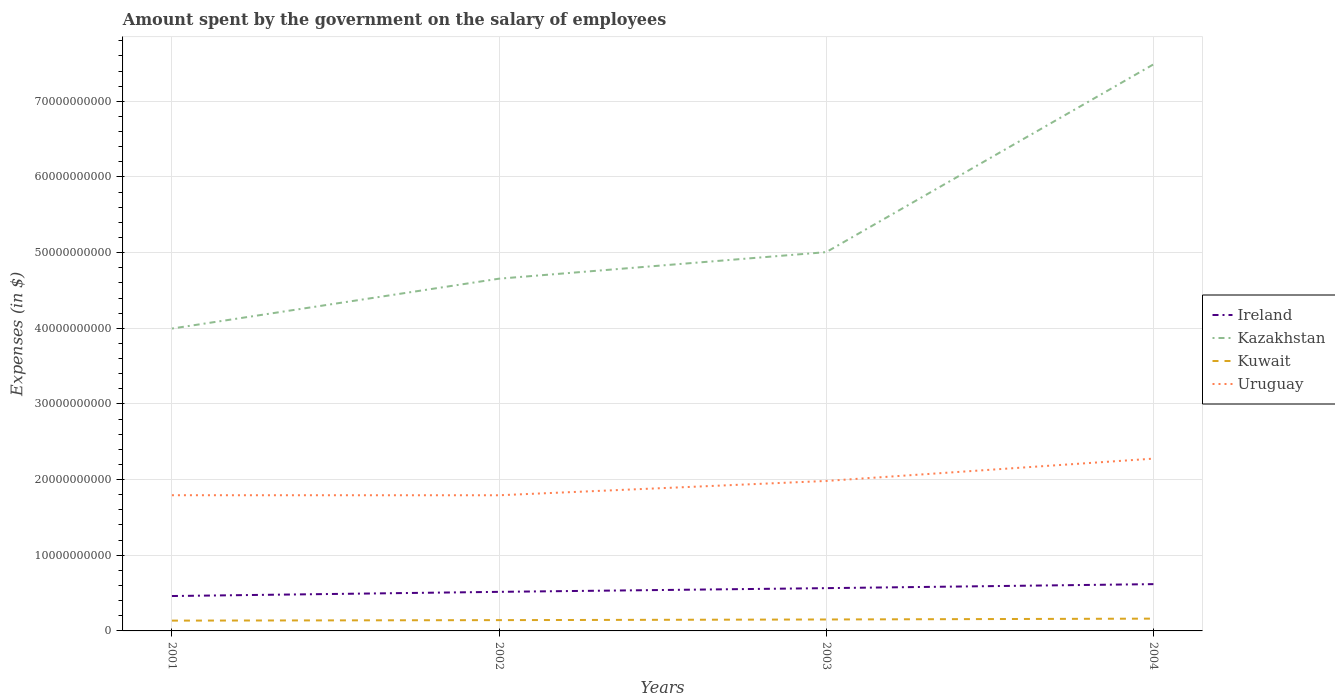How many different coloured lines are there?
Your answer should be compact. 4. Does the line corresponding to Kuwait intersect with the line corresponding to Ireland?
Ensure brevity in your answer.  No. Across all years, what is the maximum amount spent on the salary of employees by the government in Kazakhstan?
Provide a short and direct response. 4.00e+1. In which year was the amount spent on the salary of employees by the government in Kuwait maximum?
Ensure brevity in your answer.  2001. What is the total amount spent on the salary of employees by the government in Ireland in the graph?
Offer a terse response. -5.53e+08. What is the difference between the highest and the second highest amount spent on the salary of employees by the government in Kazakhstan?
Your answer should be compact. 3.49e+1. How many years are there in the graph?
Give a very brief answer. 4. Does the graph contain any zero values?
Your answer should be very brief. No. How many legend labels are there?
Your response must be concise. 4. What is the title of the graph?
Your response must be concise. Amount spent by the government on the salary of employees. What is the label or title of the Y-axis?
Ensure brevity in your answer.  Expenses (in $). What is the Expenses (in $) of Ireland in 2001?
Ensure brevity in your answer.  4.61e+09. What is the Expenses (in $) in Kazakhstan in 2001?
Your answer should be compact. 4.00e+1. What is the Expenses (in $) of Kuwait in 2001?
Keep it short and to the point. 1.36e+09. What is the Expenses (in $) in Uruguay in 2001?
Your answer should be very brief. 1.79e+1. What is the Expenses (in $) of Ireland in 2002?
Ensure brevity in your answer.  5.16e+09. What is the Expenses (in $) of Kazakhstan in 2002?
Keep it short and to the point. 4.66e+1. What is the Expenses (in $) in Kuwait in 2002?
Offer a very short reply. 1.43e+09. What is the Expenses (in $) of Uruguay in 2002?
Offer a very short reply. 1.79e+1. What is the Expenses (in $) of Ireland in 2003?
Provide a succinct answer. 5.65e+09. What is the Expenses (in $) in Kazakhstan in 2003?
Make the answer very short. 5.01e+1. What is the Expenses (in $) of Kuwait in 2003?
Offer a terse response. 1.51e+09. What is the Expenses (in $) in Uruguay in 2003?
Your response must be concise. 1.98e+1. What is the Expenses (in $) of Ireland in 2004?
Provide a short and direct response. 6.18e+09. What is the Expenses (in $) of Kazakhstan in 2004?
Keep it short and to the point. 7.49e+1. What is the Expenses (in $) in Kuwait in 2004?
Provide a succinct answer. 1.62e+09. What is the Expenses (in $) in Uruguay in 2004?
Your answer should be very brief. 2.28e+1. Across all years, what is the maximum Expenses (in $) of Ireland?
Your response must be concise. 6.18e+09. Across all years, what is the maximum Expenses (in $) of Kazakhstan?
Offer a very short reply. 7.49e+1. Across all years, what is the maximum Expenses (in $) in Kuwait?
Offer a very short reply. 1.62e+09. Across all years, what is the maximum Expenses (in $) of Uruguay?
Make the answer very short. 2.28e+1. Across all years, what is the minimum Expenses (in $) of Ireland?
Give a very brief answer. 4.61e+09. Across all years, what is the minimum Expenses (in $) in Kazakhstan?
Offer a terse response. 4.00e+1. Across all years, what is the minimum Expenses (in $) of Kuwait?
Keep it short and to the point. 1.36e+09. Across all years, what is the minimum Expenses (in $) of Uruguay?
Your answer should be very brief. 1.79e+1. What is the total Expenses (in $) in Ireland in the graph?
Make the answer very short. 2.16e+1. What is the total Expenses (in $) in Kazakhstan in the graph?
Your response must be concise. 2.11e+11. What is the total Expenses (in $) in Kuwait in the graph?
Ensure brevity in your answer.  5.93e+09. What is the total Expenses (in $) of Uruguay in the graph?
Your response must be concise. 7.85e+1. What is the difference between the Expenses (in $) in Ireland in 2001 and that in 2002?
Offer a very short reply. -5.53e+08. What is the difference between the Expenses (in $) in Kazakhstan in 2001 and that in 2002?
Your response must be concise. -6.59e+09. What is the difference between the Expenses (in $) in Kuwait in 2001 and that in 2002?
Provide a short and direct response. -6.50e+07. What is the difference between the Expenses (in $) in Uruguay in 2001 and that in 2002?
Your answer should be very brief. 5.24e+06. What is the difference between the Expenses (in $) of Ireland in 2001 and that in 2003?
Offer a terse response. -1.04e+09. What is the difference between the Expenses (in $) of Kazakhstan in 2001 and that in 2003?
Your answer should be very brief. -1.01e+1. What is the difference between the Expenses (in $) of Kuwait in 2001 and that in 2003?
Ensure brevity in your answer.  -1.50e+08. What is the difference between the Expenses (in $) in Uruguay in 2001 and that in 2003?
Keep it short and to the point. -1.89e+09. What is the difference between the Expenses (in $) in Ireland in 2001 and that in 2004?
Keep it short and to the point. -1.57e+09. What is the difference between the Expenses (in $) in Kazakhstan in 2001 and that in 2004?
Your response must be concise. -3.49e+1. What is the difference between the Expenses (in $) in Kuwait in 2001 and that in 2004?
Offer a very short reply. -2.63e+08. What is the difference between the Expenses (in $) in Uruguay in 2001 and that in 2004?
Your answer should be compact. -4.84e+09. What is the difference between the Expenses (in $) in Ireland in 2002 and that in 2003?
Give a very brief answer. -4.88e+08. What is the difference between the Expenses (in $) in Kazakhstan in 2002 and that in 2003?
Ensure brevity in your answer.  -3.51e+09. What is the difference between the Expenses (in $) of Kuwait in 2002 and that in 2003?
Provide a short and direct response. -8.50e+07. What is the difference between the Expenses (in $) of Uruguay in 2002 and that in 2003?
Make the answer very short. -1.89e+09. What is the difference between the Expenses (in $) of Ireland in 2002 and that in 2004?
Make the answer very short. -1.02e+09. What is the difference between the Expenses (in $) in Kazakhstan in 2002 and that in 2004?
Your answer should be very brief. -2.83e+1. What is the difference between the Expenses (in $) of Kuwait in 2002 and that in 2004?
Provide a succinct answer. -1.98e+08. What is the difference between the Expenses (in $) in Uruguay in 2002 and that in 2004?
Your answer should be compact. -4.84e+09. What is the difference between the Expenses (in $) of Ireland in 2003 and that in 2004?
Your response must be concise. -5.31e+08. What is the difference between the Expenses (in $) in Kazakhstan in 2003 and that in 2004?
Give a very brief answer. -2.48e+1. What is the difference between the Expenses (in $) of Kuwait in 2003 and that in 2004?
Your answer should be very brief. -1.13e+08. What is the difference between the Expenses (in $) in Uruguay in 2003 and that in 2004?
Ensure brevity in your answer.  -2.95e+09. What is the difference between the Expenses (in $) in Ireland in 2001 and the Expenses (in $) in Kazakhstan in 2002?
Give a very brief answer. -4.19e+1. What is the difference between the Expenses (in $) of Ireland in 2001 and the Expenses (in $) of Kuwait in 2002?
Offer a terse response. 3.18e+09. What is the difference between the Expenses (in $) of Ireland in 2001 and the Expenses (in $) of Uruguay in 2002?
Keep it short and to the point. -1.33e+1. What is the difference between the Expenses (in $) of Kazakhstan in 2001 and the Expenses (in $) of Kuwait in 2002?
Keep it short and to the point. 3.85e+1. What is the difference between the Expenses (in $) of Kazakhstan in 2001 and the Expenses (in $) of Uruguay in 2002?
Your response must be concise. 2.20e+1. What is the difference between the Expenses (in $) in Kuwait in 2001 and the Expenses (in $) in Uruguay in 2002?
Your answer should be very brief. -1.66e+1. What is the difference between the Expenses (in $) in Ireland in 2001 and the Expenses (in $) in Kazakhstan in 2003?
Provide a succinct answer. -4.55e+1. What is the difference between the Expenses (in $) of Ireland in 2001 and the Expenses (in $) of Kuwait in 2003?
Your answer should be compact. 3.10e+09. What is the difference between the Expenses (in $) of Ireland in 2001 and the Expenses (in $) of Uruguay in 2003?
Your response must be concise. -1.52e+1. What is the difference between the Expenses (in $) of Kazakhstan in 2001 and the Expenses (in $) of Kuwait in 2003?
Your answer should be very brief. 3.85e+1. What is the difference between the Expenses (in $) of Kazakhstan in 2001 and the Expenses (in $) of Uruguay in 2003?
Provide a succinct answer. 2.01e+1. What is the difference between the Expenses (in $) of Kuwait in 2001 and the Expenses (in $) of Uruguay in 2003?
Keep it short and to the point. -1.85e+1. What is the difference between the Expenses (in $) in Ireland in 2001 and the Expenses (in $) in Kazakhstan in 2004?
Keep it short and to the point. -7.03e+1. What is the difference between the Expenses (in $) of Ireland in 2001 and the Expenses (in $) of Kuwait in 2004?
Keep it short and to the point. 2.99e+09. What is the difference between the Expenses (in $) in Ireland in 2001 and the Expenses (in $) in Uruguay in 2004?
Ensure brevity in your answer.  -1.82e+1. What is the difference between the Expenses (in $) in Kazakhstan in 2001 and the Expenses (in $) in Kuwait in 2004?
Ensure brevity in your answer.  3.83e+1. What is the difference between the Expenses (in $) of Kazakhstan in 2001 and the Expenses (in $) of Uruguay in 2004?
Your answer should be very brief. 1.72e+1. What is the difference between the Expenses (in $) of Kuwait in 2001 and the Expenses (in $) of Uruguay in 2004?
Offer a terse response. -2.14e+1. What is the difference between the Expenses (in $) of Ireland in 2002 and the Expenses (in $) of Kazakhstan in 2003?
Provide a short and direct response. -4.49e+1. What is the difference between the Expenses (in $) in Ireland in 2002 and the Expenses (in $) in Kuwait in 2003?
Provide a succinct answer. 3.65e+09. What is the difference between the Expenses (in $) in Ireland in 2002 and the Expenses (in $) in Uruguay in 2003?
Ensure brevity in your answer.  -1.47e+1. What is the difference between the Expenses (in $) of Kazakhstan in 2002 and the Expenses (in $) of Kuwait in 2003?
Your answer should be very brief. 4.50e+1. What is the difference between the Expenses (in $) in Kazakhstan in 2002 and the Expenses (in $) in Uruguay in 2003?
Keep it short and to the point. 2.67e+1. What is the difference between the Expenses (in $) of Kuwait in 2002 and the Expenses (in $) of Uruguay in 2003?
Your answer should be very brief. -1.84e+1. What is the difference between the Expenses (in $) of Ireland in 2002 and the Expenses (in $) of Kazakhstan in 2004?
Your response must be concise. -6.97e+1. What is the difference between the Expenses (in $) in Ireland in 2002 and the Expenses (in $) in Kuwait in 2004?
Offer a very short reply. 3.54e+09. What is the difference between the Expenses (in $) in Ireland in 2002 and the Expenses (in $) in Uruguay in 2004?
Provide a short and direct response. -1.76e+1. What is the difference between the Expenses (in $) of Kazakhstan in 2002 and the Expenses (in $) of Kuwait in 2004?
Provide a succinct answer. 4.49e+1. What is the difference between the Expenses (in $) of Kazakhstan in 2002 and the Expenses (in $) of Uruguay in 2004?
Keep it short and to the point. 2.38e+1. What is the difference between the Expenses (in $) of Kuwait in 2002 and the Expenses (in $) of Uruguay in 2004?
Keep it short and to the point. -2.13e+1. What is the difference between the Expenses (in $) of Ireland in 2003 and the Expenses (in $) of Kazakhstan in 2004?
Your answer should be compact. -6.92e+1. What is the difference between the Expenses (in $) in Ireland in 2003 and the Expenses (in $) in Kuwait in 2004?
Give a very brief answer. 4.03e+09. What is the difference between the Expenses (in $) of Ireland in 2003 and the Expenses (in $) of Uruguay in 2004?
Your answer should be very brief. -1.71e+1. What is the difference between the Expenses (in $) in Kazakhstan in 2003 and the Expenses (in $) in Kuwait in 2004?
Make the answer very short. 4.84e+1. What is the difference between the Expenses (in $) of Kazakhstan in 2003 and the Expenses (in $) of Uruguay in 2004?
Keep it short and to the point. 2.73e+1. What is the difference between the Expenses (in $) of Kuwait in 2003 and the Expenses (in $) of Uruguay in 2004?
Make the answer very short. -2.13e+1. What is the average Expenses (in $) of Ireland per year?
Give a very brief answer. 5.40e+09. What is the average Expenses (in $) in Kazakhstan per year?
Ensure brevity in your answer.  5.29e+1. What is the average Expenses (in $) of Kuwait per year?
Ensure brevity in your answer.  1.48e+09. What is the average Expenses (in $) of Uruguay per year?
Give a very brief answer. 1.96e+1. In the year 2001, what is the difference between the Expenses (in $) of Ireland and Expenses (in $) of Kazakhstan?
Your response must be concise. -3.54e+1. In the year 2001, what is the difference between the Expenses (in $) in Ireland and Expenses (in $) in Kuwait?
Provide a short and direct response. 3.25e+09. In the year 2001, what is the difference between the Expenses (in $) of Ireland and Expenses (in $) of Uruguay?
Provide a short and direct response. -1.33e+1. In the year 2001, what is the difference between the Expenses (in $) in Kazakhstan and Expenses (in $) in Kuwait?
Provide a succinct answer. 3.86e+1. In the year 2001, what is the difference between the Expenses (in $) of Kazakhstan and Expenses (in $) of Uruguay?
Your answer should be compact. 2.20e+1. In the year 2001, what is the difference between the Expenses (in $) in Kuwait and Expenses (in $) in Uruguay?
Ensure brevity in your answer.  -1.66e+1. In the year 2002, what is the difference between the Expenses (in $) of Ireland and Expenses (in $) of Kazakhstan?
Make the answer very short. -4.14e+1. In the year 2002, what is the difference between the Expenses (in $) in Ireland and Expenses (in $) in Kuwait?
Ensure brevity in your answer.  3.74e+09. In the year 2002, what is the difference between the Expenses (in $) in Ireland and Expenses (in $) in Uruguay?
Provide a short and direct response. -1.28e+1. In the year 2002, what is the difference between the Expenses (in $) in Kazakhstan and Expenses (in $) in Kuwait?
Your response must be concise. 4.51e+1. In the year 2002, what is the difference between the Expenses (in $) of Kazakhstan and Expenses (in $) of Uruguay?
Give a very brief answer. 2.86e+1. In the year 2002, what is the difference between the Expenses (in $) in Kuwait and Expenses (in $) in Uruguay?
Keep it short and to the point. -1.65e+1. In the year 2003, what is the difference between the Expenses (in $) in Ireland and Expenses (in $) in Kazakhstan?
Offer a terse response. -4.44e+1. In the year 2003, what is the difference between the Expenses (in $) in Ireland and Expenses (in $) in Kuwait?
Provide a short and direct response. 4.14e+09. In the year 2003, what is the difference between the Expenses (in $) of Ireland and Expenses (in $) of Uruguay?
Keep it short and to the point. -1.42e+1. In the year 2003, what is the difference between the Expenses (in $) of Kazakhstan and Expenses (in $) of Kuwait?
Your answer should be very brief. 4.86e+1. In the year 2003, what is the difference between the Expenses (in $) of Kazakhstan and Expenses (in $) of Uruguay?
Ensure brevity in your answer.  3.02e+1. In the year 2003, what is the difference between the Expenses (in $) of Kuwait and Expenses (in $) of Uruguay?
Offer a very short reply. -1.83e+1. In the year 2004, what is the difference between the Expenses (in $) of Ireland and Expenses (in $) of Kazakhstan?
Offer a terse response. -6.87e+1. In the year 2004, what is the difference between the Expenses (in $) of Ireland and Expenses (in $) of Kuwait?
Offer a terse response. 4.56e+09. In the year 2004, what is the difference between the Expenses (in $) of Ireland and Expenses (in $) of Uruguay?
Your answer should be compact. -1.66e+1. In the year 2004, what is the difference between the Expenses (in $) in Kazakhstan and Expenses (in $) in Kuwait?
Offer a very short reply. 7.33e+1. In the year 2004, what is the difference between the Expenses (in $) of Kazakhstan and Expenses (in $) of Uruguay?
Offer a very short reply. 5.21e+1. In the year 2004, what is the difference between the Expenses (in $) in Kuwait and Expenses (in $) in Uruguay?
Your response must be concise. -2.11e+1. What is the ratio of the Expenses (in $) in Ireland in 2001 to that in 2002?
Your response must be concise. 0.89. What is the ratio of the Expenses (in $) in Kazakhstan in 2001 to that in 2002?
Offer a terse response. 0.86. What is the ratio of the Expenses (in $) in Kuwait in 2001 to that in 2002?
Your answer should be compact. 0.95. What is the ratio of the Expenses (in $) of Ireland in 2001 to that in 2003?
Your answer should be very brief. 0.82. What is the ratio of the Expenses (in $) in Kazakhstan in 2001 to that in 2003?
Your response must be concise. 0.8. What is the ratio of the Expenses (in $) of Kuwait in 2001 to that in 2003?
Give a very brief answer. 0.9. What is the ratio of the Expenses (in $) of Uruguay in 2001 to that in 2003?
Give a very brief answer. 0.9. What is the ratio of the Expenses (in $) of Ireland in 2001 to that in 2004?
Provide a short and direct response. 0.75. What is the ratio of the Expenses (in $) in Kazakhstan in 2001 to that in 2004?
Provide a short and direct response. 0.53. What is the ratio of the Expenses (in $) of Kuwait in 2001 to that in 2004?
Provide a short and direct response. 0.84. What is the ratio of the Expenses (in $) of Uruguay in 2001 to that in 2004?
Keep it short and to the point. 0.79. What is the ratio of the Expenses (in $) of Ireland in 2002 to that in 2003?
Your answer should be compact. 0.91. What is the ratio of the Expenses (in $) of Kazakhstan in 2002 to that in 2003?
Keep it short and to the point. 0.93. What is the ratio of the Expenses (in $) in Kuwait in 2002 to that in 2003?
Your answer should be compact. 0.94. What is the ratio of the Expenses (in $) in Uruguay in 2002 to that in 2003?
Your answer should be very brief. 0.9. What is the ratio of the Expenses (in $) in Ireland in 2002 to that in 2004?
Provide a short and direct response. 0.84. What is the ratio of the Expenses (in $) in Kazakhstan in 2002 to that in 2004?
Provide a succinct answer. 0.62. What is the ratio of the Expenses (in $) in Kuwait in 2002 to that in 2004?
Your answer should be compact. 0.88. What is the ratio of the Expenses (in $) of Uruguay in 2002 to that in 2004?
Offer a very short reply. 0.79. What is the ratio of the Expenses (in $) of Ireland in 2003 to that in 2004?
Ensure brevity in your answer.  0.91. What is the ratio of the Expenses (in $) in Kazakhstan in 2003 to that in 2004?
Your response must be concise. 0.67. What is the ratio of the Expenses (in $) of Kuwait in 2003 to that in 2004?
Offer a terse response. 0.93. What is the ratio of the Expenses (in $) in Uruguay in 2003 to that in 2004?
Your answer should be very brief. 0.87. What is the difference between the highest and the second highest Expenses (in $) of Ireland?
Make the answer very short. 5.31e+08. What is the difference between the highest and the second highest Expenses (in $) of Kazakhstan?
Keep it short and to the point. 2.48e+1. What is the difference between the highest and the second highest Expenses (in $) in Kuwait?
Provide a short and direct response. 1.13e+08. What is the difference between the highest and the second highest Expenses (in $) of Uruguay?
Ensure brevity in your answer.  2.95e+09. What is the difference between the highest and the lowest Expenses (in $) in Ireland?
Your answer should be compact. 1.57e+09. What is the difference between the highest and the lowest Expenses (in $) of Kazakhstan?
Offer a terse response. 3.49e+1. What is the difference between the highest and the lowest Expenses (in $) of Kuwait?
Keep it short and to the point. 2.63e+08. What is the difference between the highest and the lowest Expenses (in $) in Uruguay?
Ensure brevity in your answer.  4.84e+09. 